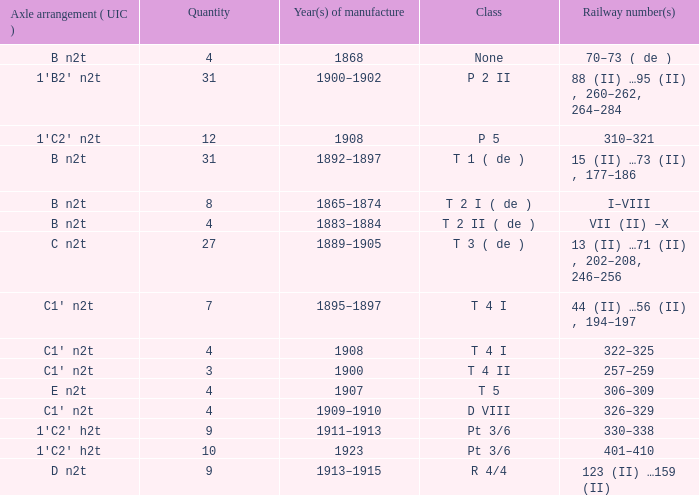What is the railway number of t 4 ii class? 257–259. 